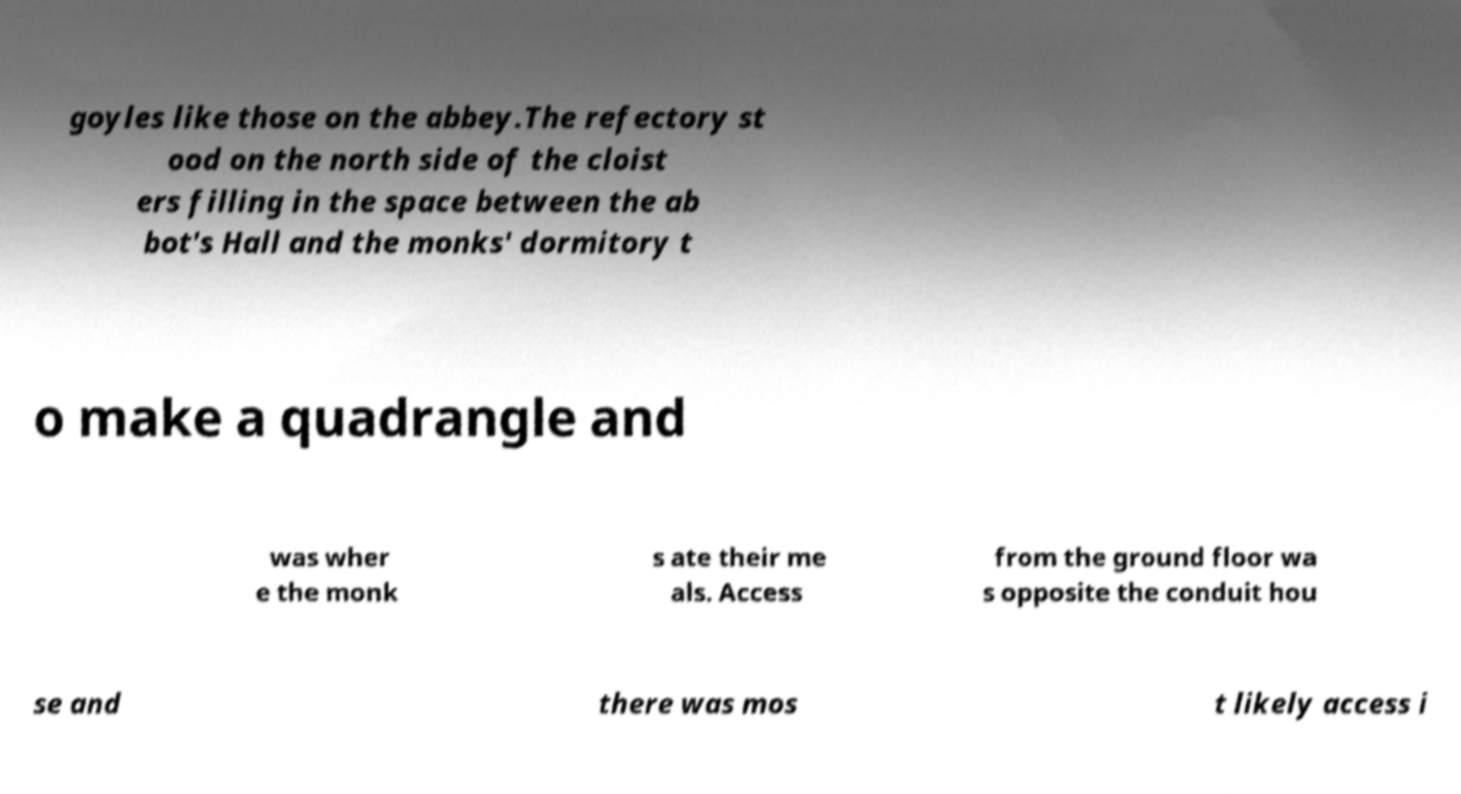Can you read and provide the text displayed in the image?This photo seems to have some interesting text. Can you extract and type it out for me? goyles like those on the abbey.The refectory st ood on the north side of the cloist ers filling in the space between the ab bot's Hall and the monks' dormitory t o make a quadrangle and was wher e the monk s ate their me als. Access from the ground floor wa s opposite the conduit hou se and there was mos t likely access i 